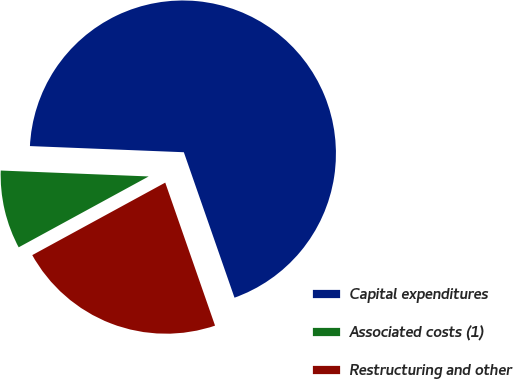Convert chart to OTSL. <chart><loc_0><loc_0><loc_500><loc_500><pie_chart><fcel>Capital expenditures<fcel>Associated costs (1)<fcel>Restructuring and other<nl><fcel>69.03%<fcel>8.58%<fcel>22.39%<nl></chart> 